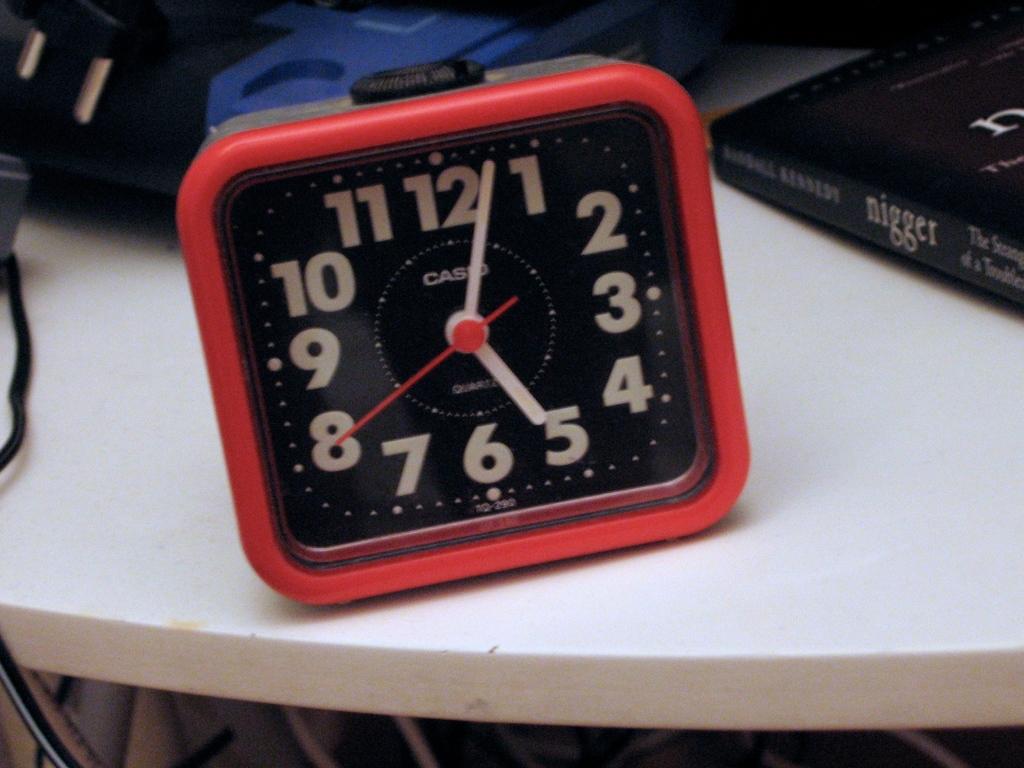What time is displayed?
Your answer should be compact. 5:03. What brand is the clock?
Keep it short and to the point. Casio. 